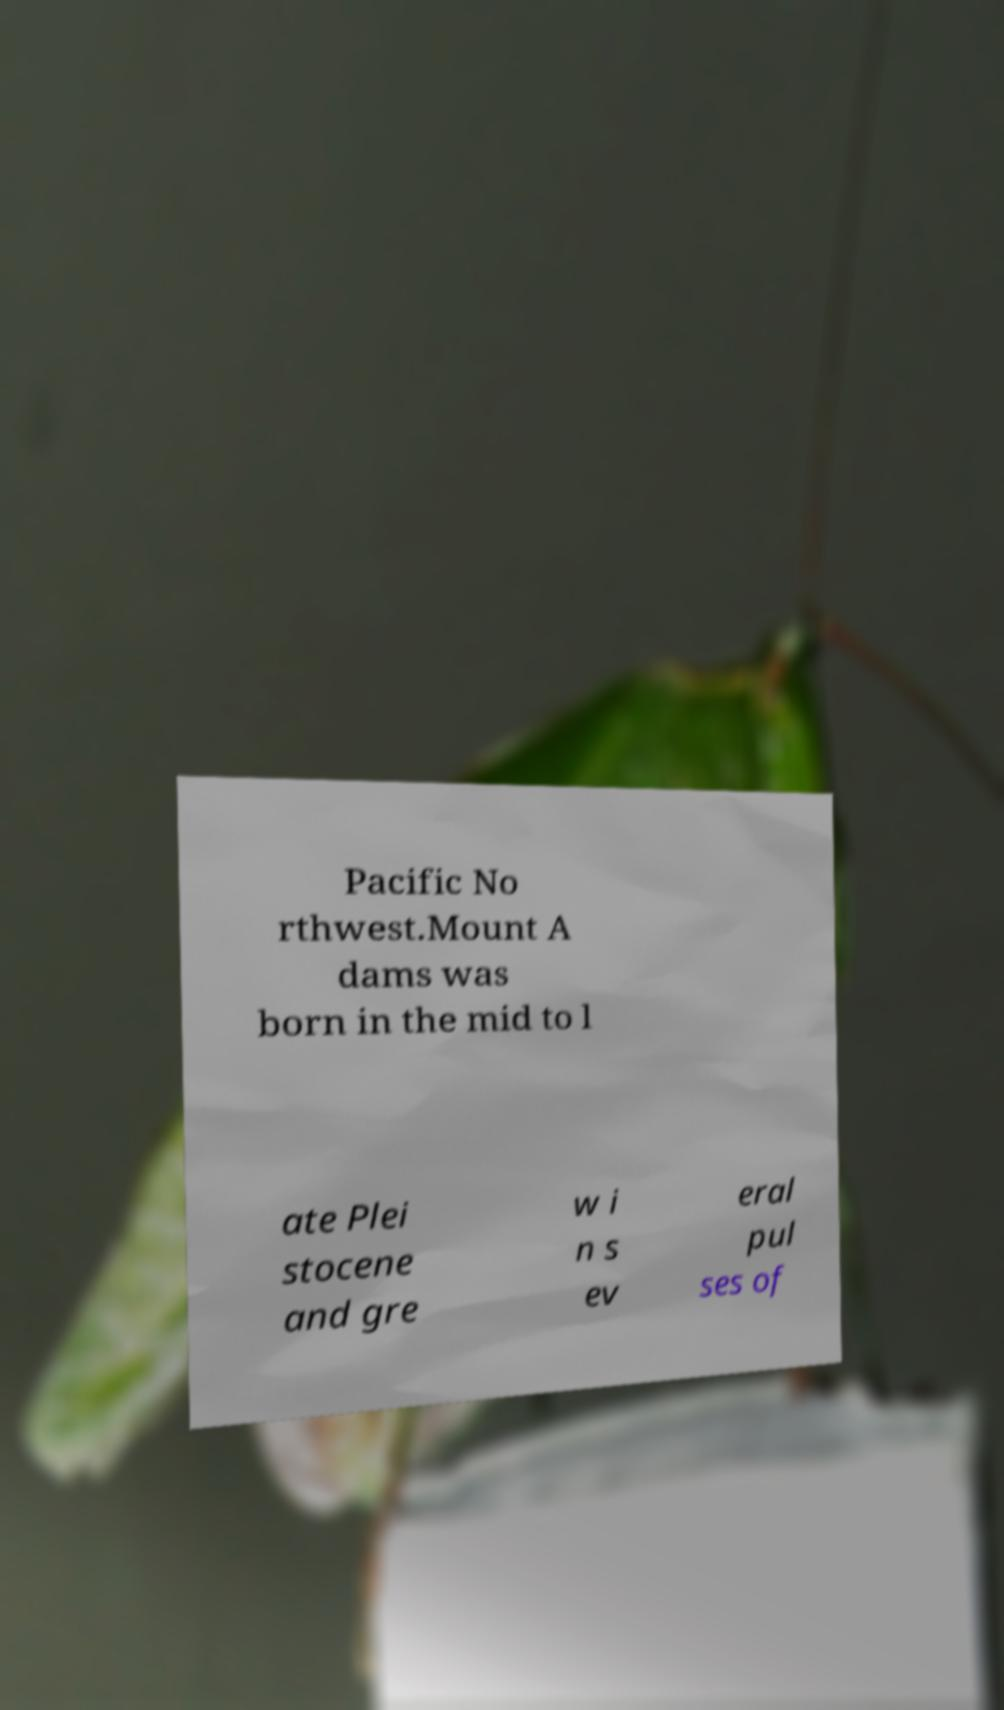What messages or text are displayed in this image? I need them in a readable, typed format. Pacific No rthwest.Mount A dams was born in the mid to l ate Plei stocene and gre w i n s ev eral pul ses of 